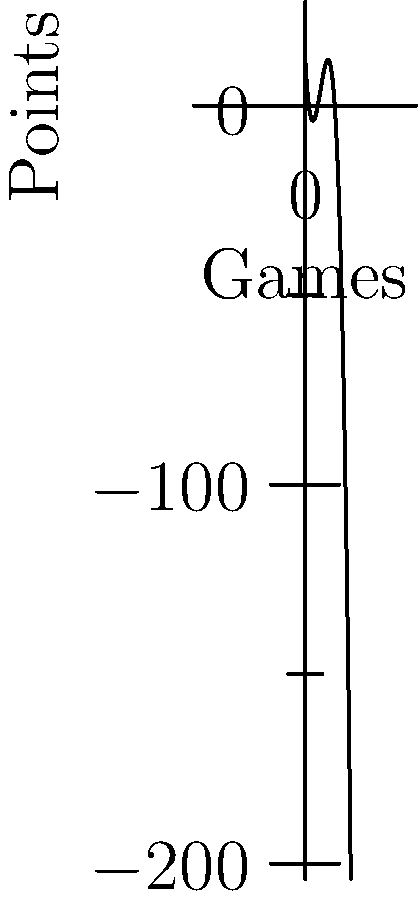Your nephew's basketball team's scoring pattern over a 12-game season can be modeled by the polynomial function $f(x) = -0.5x^3 + 6x^2 - 18x + 12$, where $x$ represents the game number and $f(x)$ represents the points scored. How many games did the team score exactly 12 points? To find the number of games where the team scored exactly 12 points, we need to solve the equation:

$f(x) = 12$

$-0.5x^3 + 6x^2 - 18x + 12 = 12$

Simplifying:

$-0.5x^3 + 6x^2 - 18x = 0$

Factoring out the common factor:

$-0.5x(x^2 - 12x + 36) = 0$

Factoring further:

$-0.5x(x - 6)(x - 6) = 0$

The solutions to this equation are:

$x = 0$ or $x = 6$

However, $x = 0$ is not a valid solution as the game numbers start from 1.

Therefore, the team scored exactly 12 points in one game, which was the 6th game of the season.
Answer: 1 game 